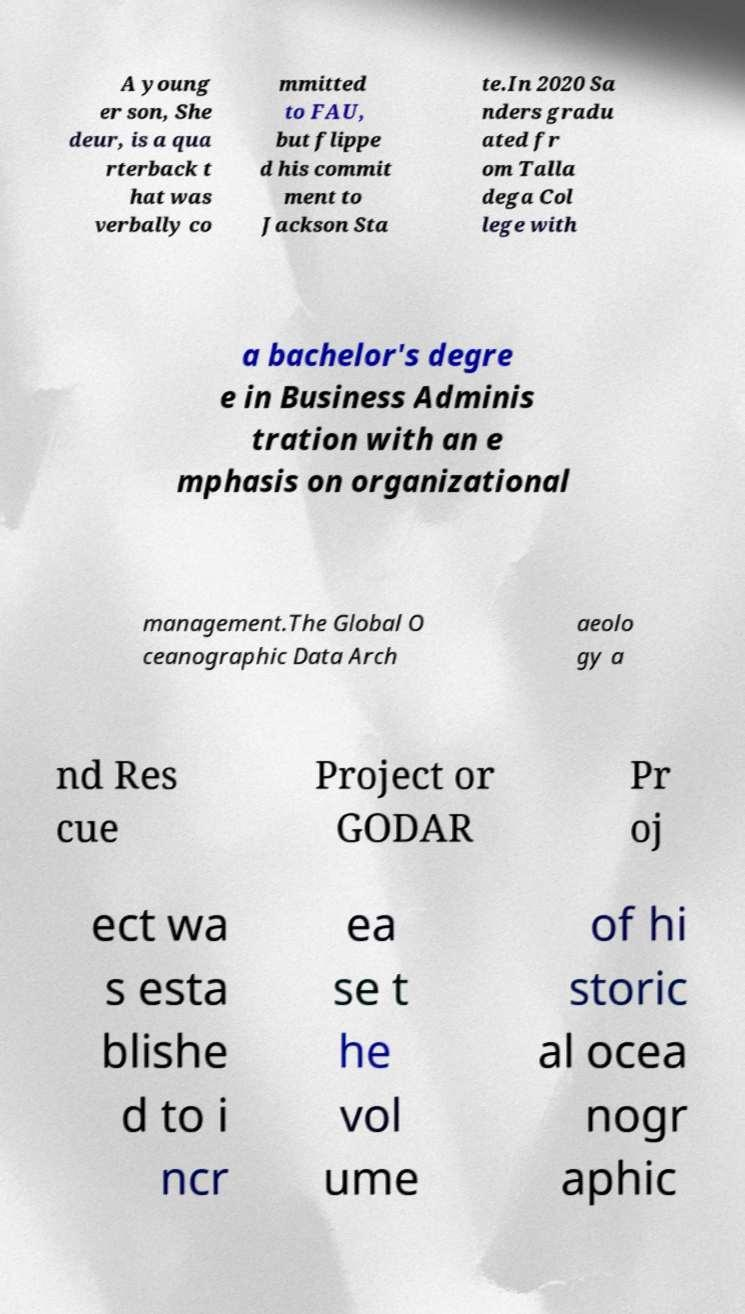For documentation purposes, I need the text within this image transcribed. Could you provide that? A young er son, She deur, is a qua rterback t hat was verbally co mmitted to FAU, but flippe d his commit ment to Jackson Sta te.In 2020 Sa nders gradu ated fr om Talla dega Col lege with a bachelor's degre e in Business Adminis tration with an e mphasis on organizational management.The Global O ceanographic Data Arch aeolo gy a nd Res cue Project or GODAR Pr oj ect wa s esta blishe d to i ncr ea se t he vol ume of hi storic al ocea nogr aphic 